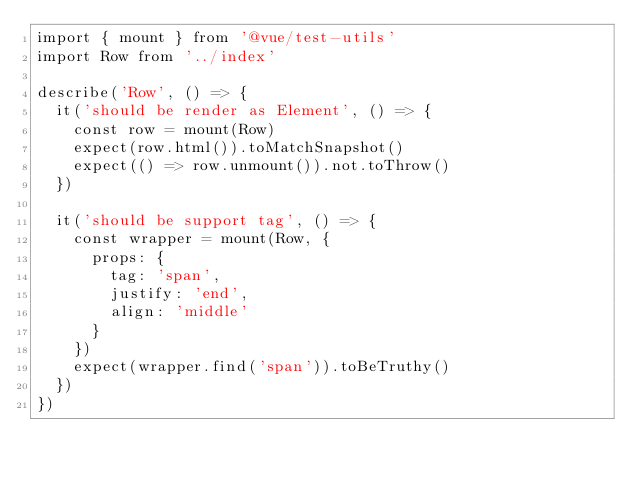Convert code to text. <code><loc_0><loc_0><loc_500><loc_500><_TypeScript_>import { mount } from '@vue/test-utils'
import Row from '../index'

describe('Row', () => {
  it('should be render as Element', () => {
    const row = mount(Row)
    expect(row.html()).toMatchSnapshot()
    expect(() => row.unmount()).not.toThrow()
  })

  it('should be support tag', () => {
    const wrapper = mount(Row, {
      props: {
        tag: 'span',
        justify: 'end',
        align: 'middle'
      }
    })
    expect(wrapper.find('span')).toBeTruthy()
  })
})
</code> 